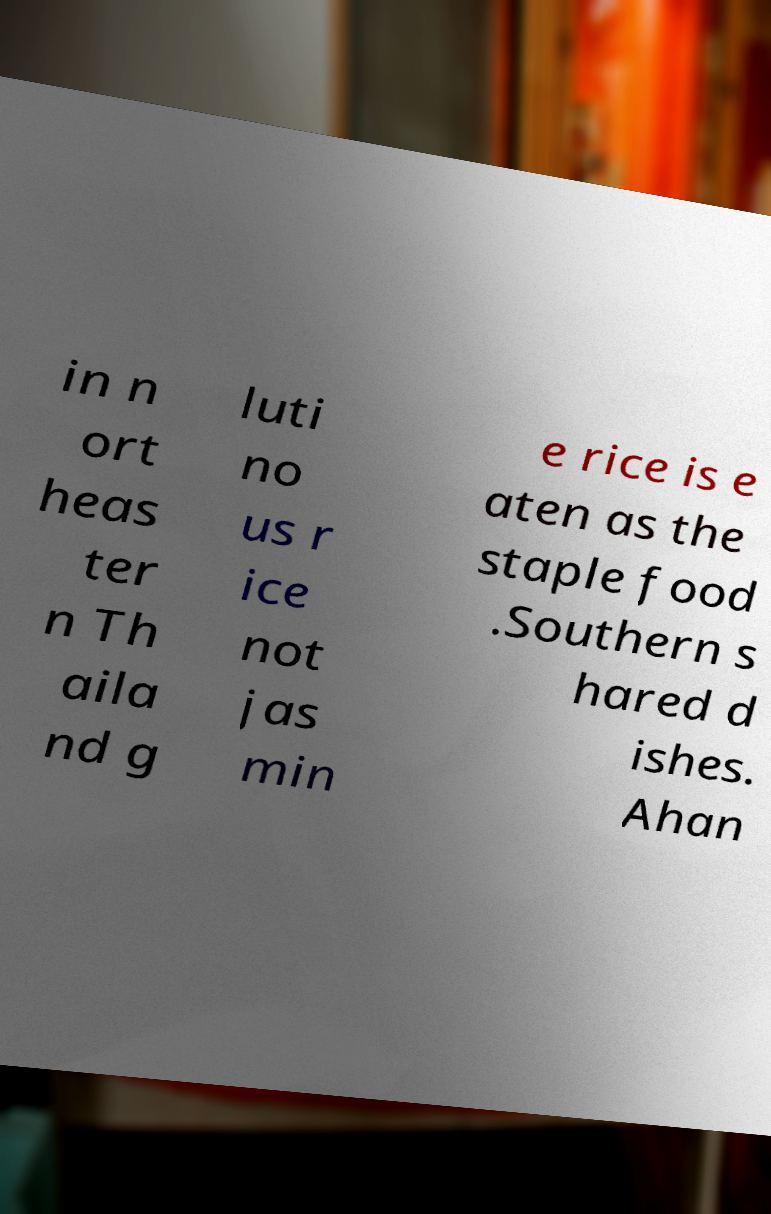What messages or text are displayed in this image? I need them in a readable, typed format. in n ort heas ter n Th aila nd g luti no us r ice not jas min e rice is e aten as the staple food .Southern s hared d ishes. Ahan 